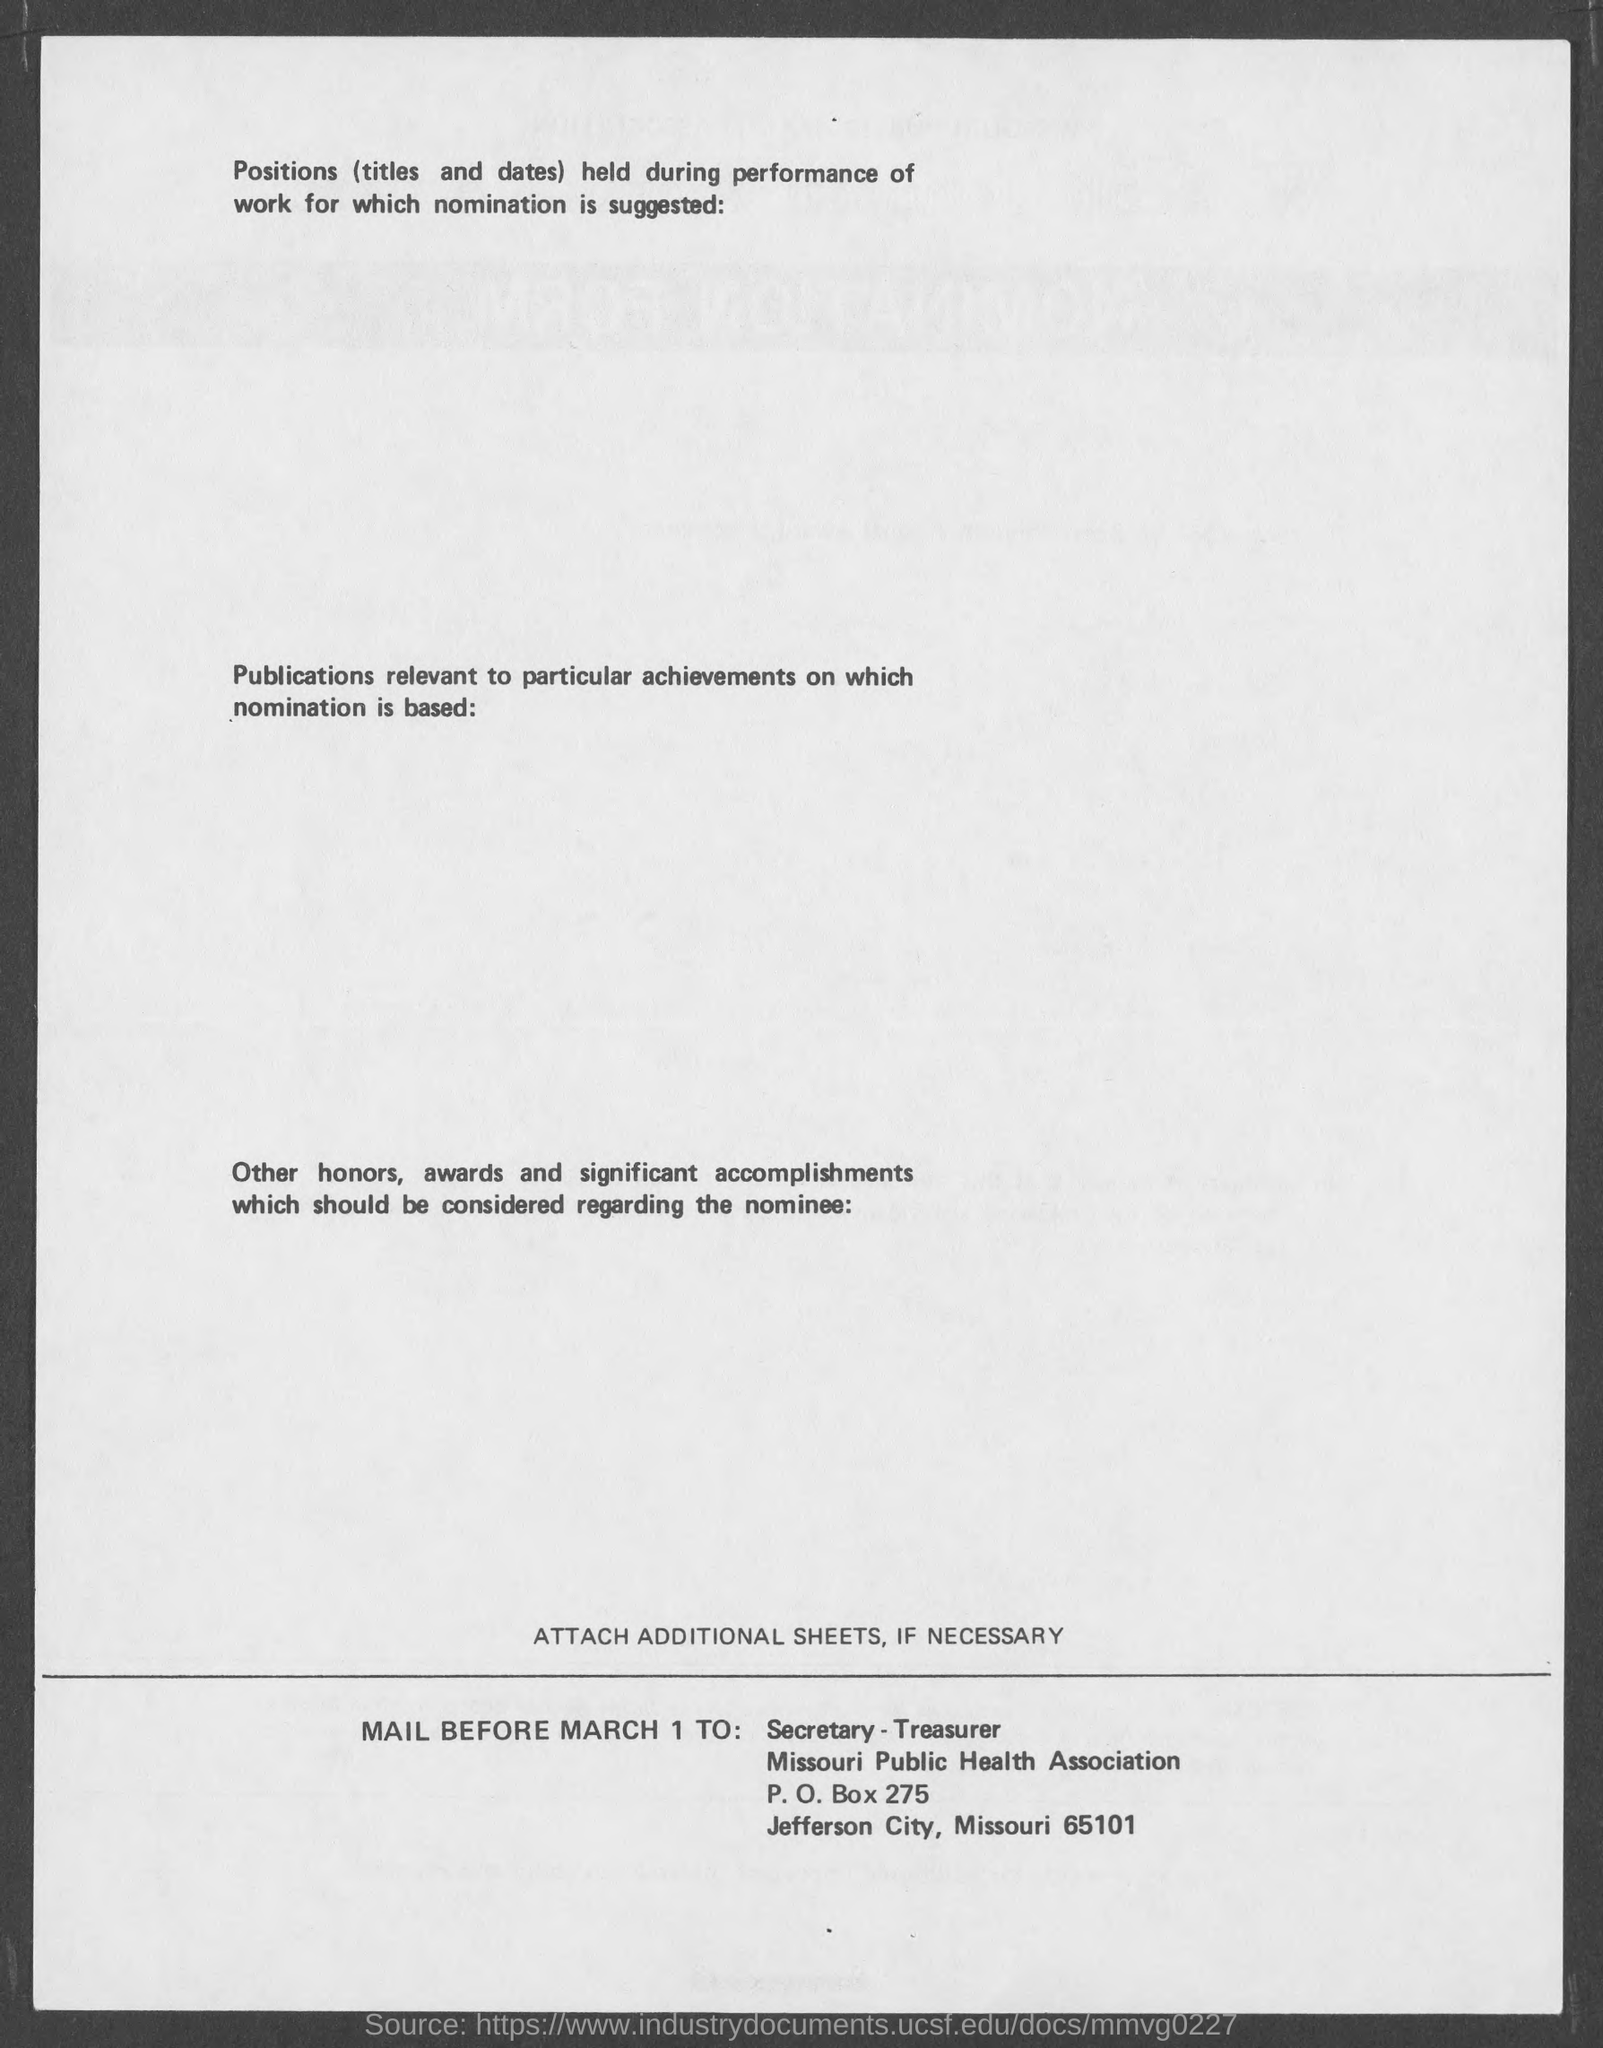Outline some significant characteristics in this image. The P.O Box number is 275. The city named in the document is Jefferson City, Missouri. The ZIP code is 65101. 